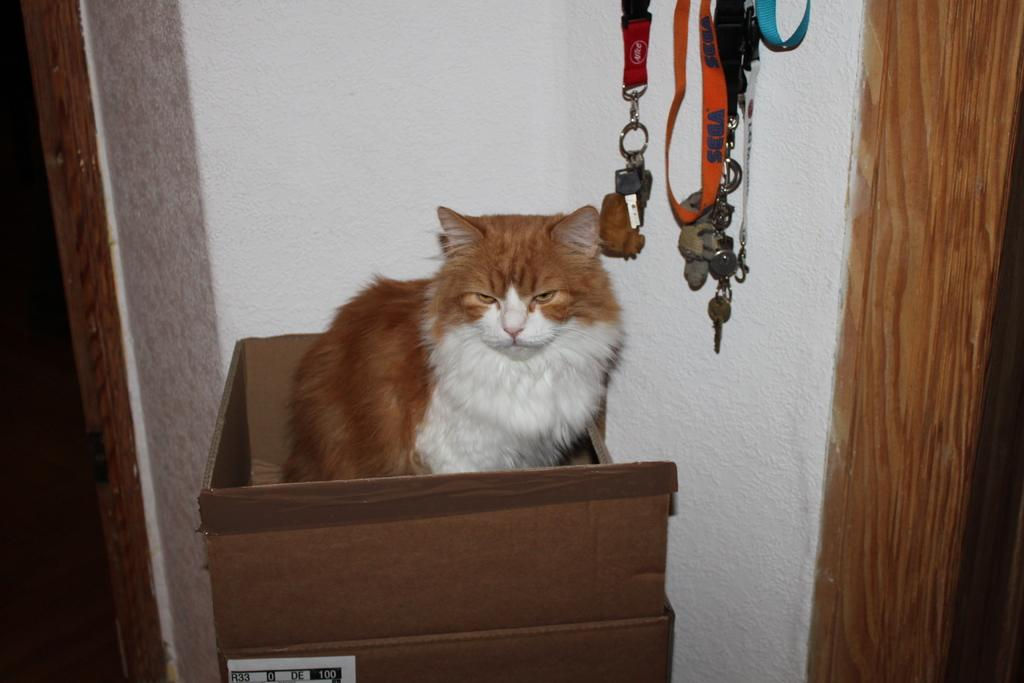What is the main subject in the foreground of the image? There is a cat in the foreground of the image. What is the cat sitting on? The cat is sitting in a cardboard box. What can be seen in the background of the image? There is a wall in the background of the image, along with ID tags and chains hanging. What type of guitar is the cat playing in the image? There is no guitar present in the image; the cat is sitting in a cardboard box. 